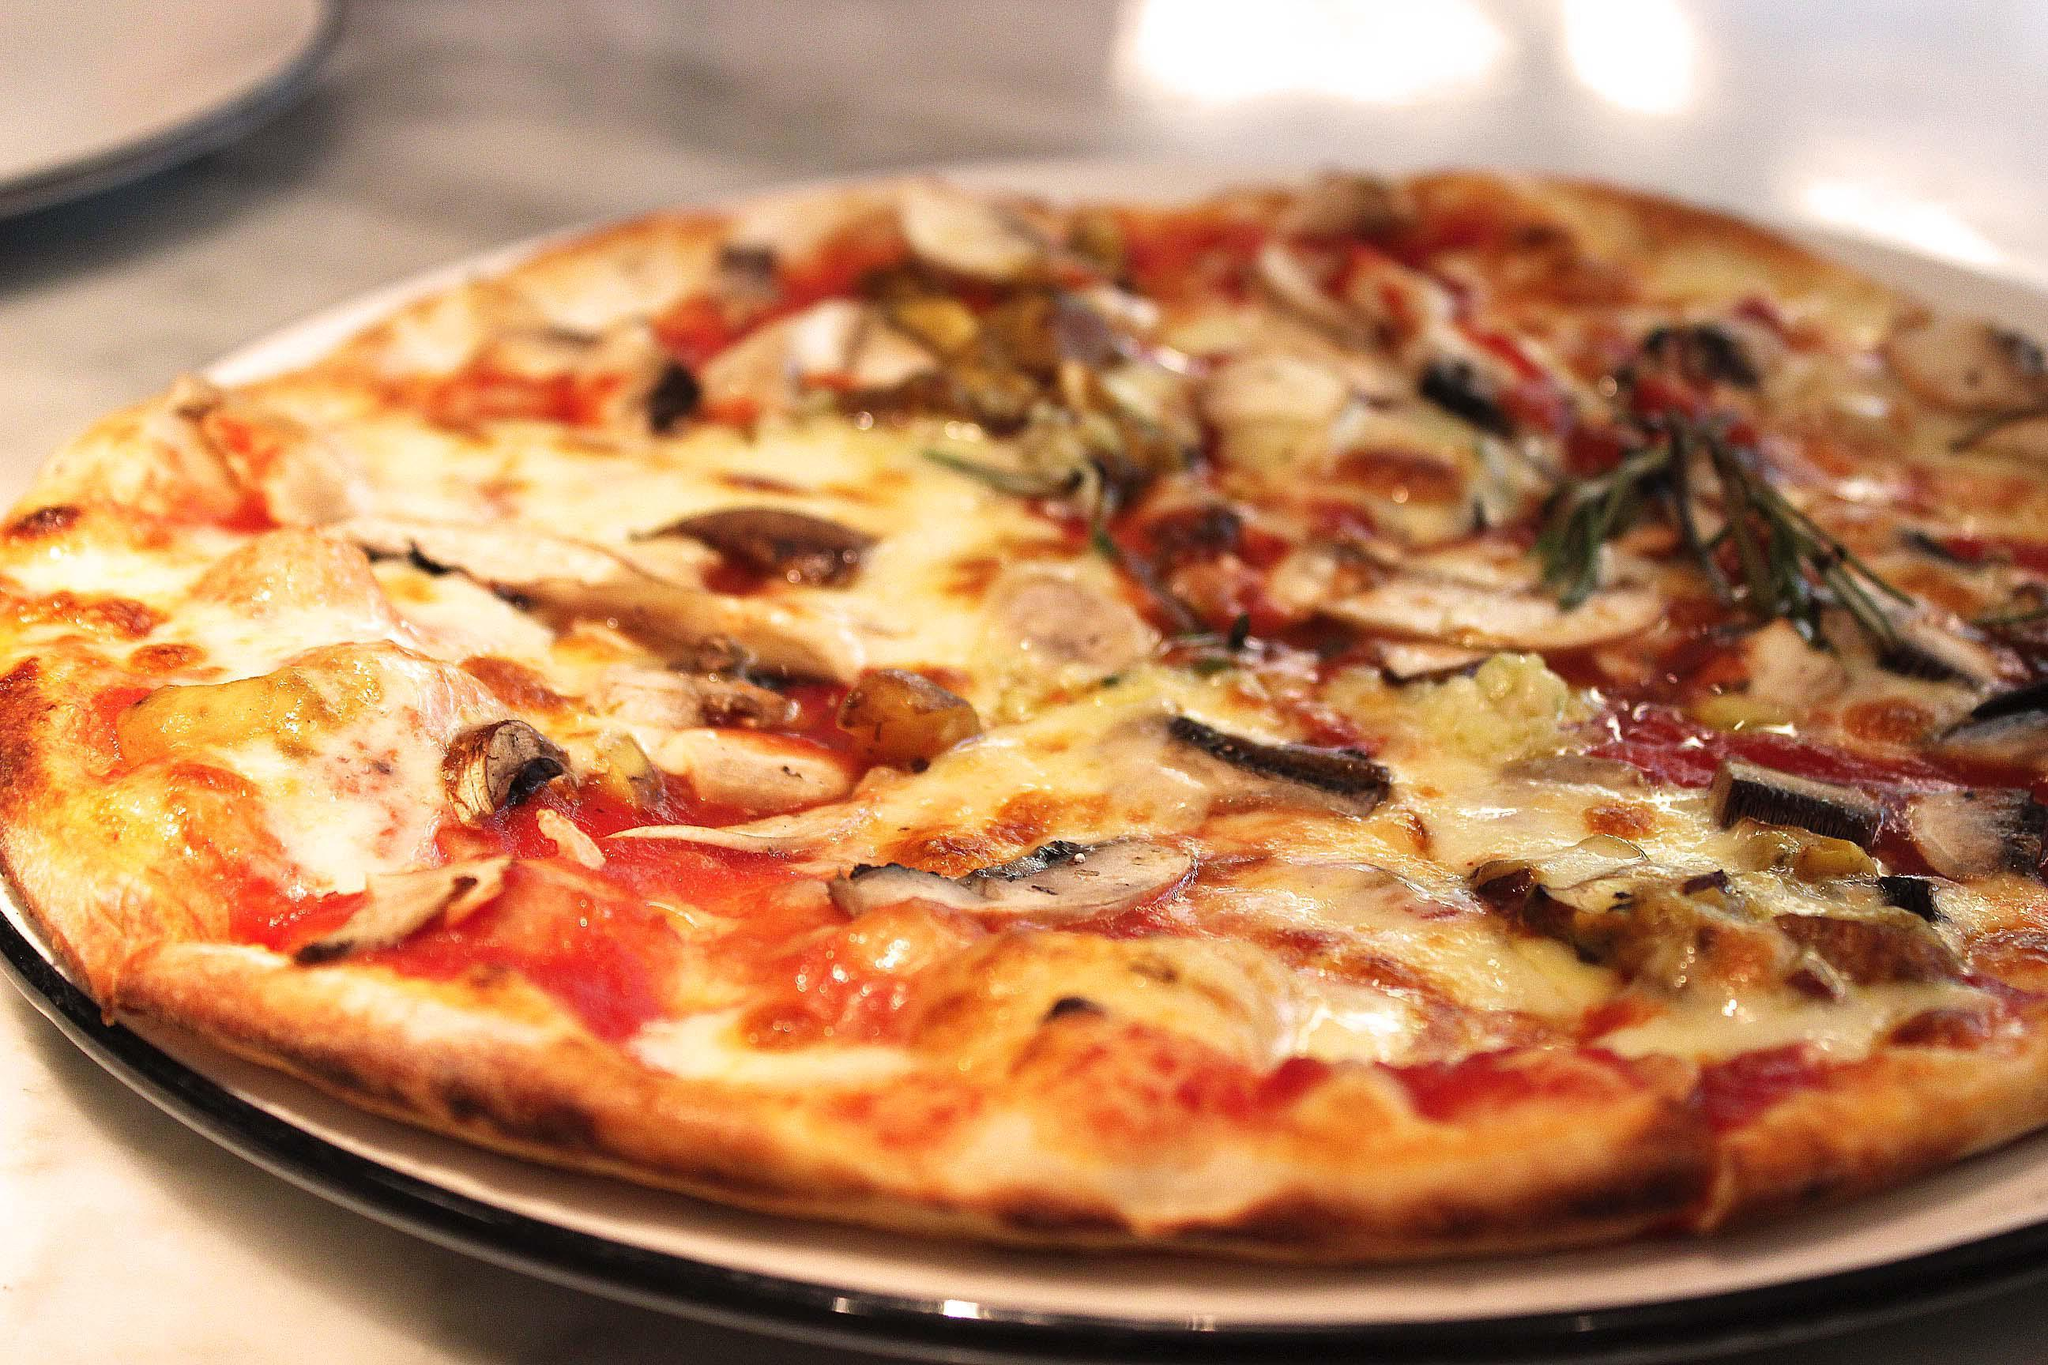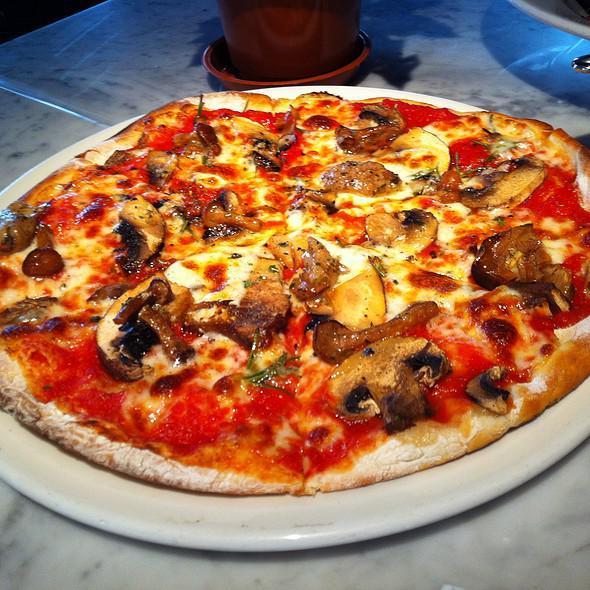The first image is the image on the left, the second image is the image on the right. Examine the images to the left and right. Is the description "Two round baked pizzas are on plates, one of them topped with stemmed mushroom pieces." accurate? Answer yes or no. Yes. The first image is the image on the left, the second image is the image on the right. Assess this claim about the two images: "In at least one image there is a pizza on a white plate with silver edging in front of a white tea cup.". Correct or not? Answer yes or no. No. 